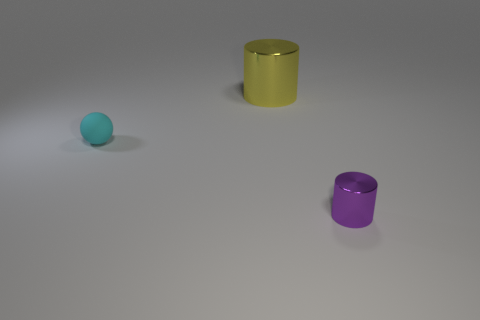Are there any large cylinders that have the same material as the small purple thing?
Give a very brief answer. Yes. How many objects are either metal cylinders that are on the right side of the big shiny cylinder or red rubber things?
Your answer should be compact. 1. Are any cyan objects visible?
Offer a terse response. Yes. There is a object that is both right of the cyan ball and in front of the big thing; what shape is it?
Keep it short and to the point. Cylinder. There is a shiny thing behind the tiny rubber sphere; what size is it?
Offer a terse response. Large. There is a cylinder behind the cyan ball; is it the same color as the small matte ball?
Make the answer very short. No. What number of other shiny objects are the same shape as the large yellow object?
Provide a succinct answer. 1. What number of objects are metallic cylinders that are behind the purple shiny cylinder or small objects to the left of the small purple thing?
Offer a terse response. 2. What number of purple objects are tiny shiny cylinders or small things?
Provide a succinct answer. 1. The thing that is both behind the purple shiny cylinder and in front of the large metallic cylinder is made of what material?
Provide a short and direct response. Rubber. 